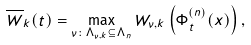Convert formula to latex. <formula><loc_0><loc_0><loc_500><loc_500>\overline { W } _ { k } ( t ) = \max _ { \nu \colon \Lambda _ { \nu , k } \subseteq \Lambda _ { n } } W _ { \nu , k } \left ( \Phi _ { t } ^ { ( n ) } ( x ) \right ) ,</formula> 